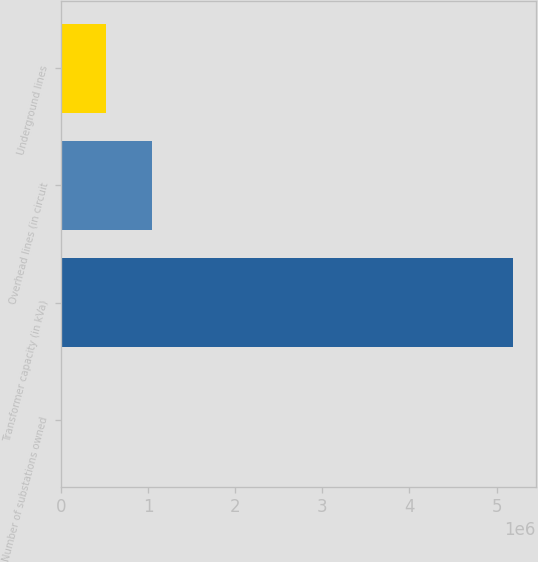Convert chart to OTSL. <chart><loc_0><loc_0><loc_500><loc_500><bar_chart><fcel>Number of substations owned<fcel>Transformer capacity (in kVa)<fcel>Overhead lines (in circuit<fcel>Underground lines<nl><fcel>43<fcel>5.191e+06<fcel>1.03823e+06<fcel>519139<nl></chart> 